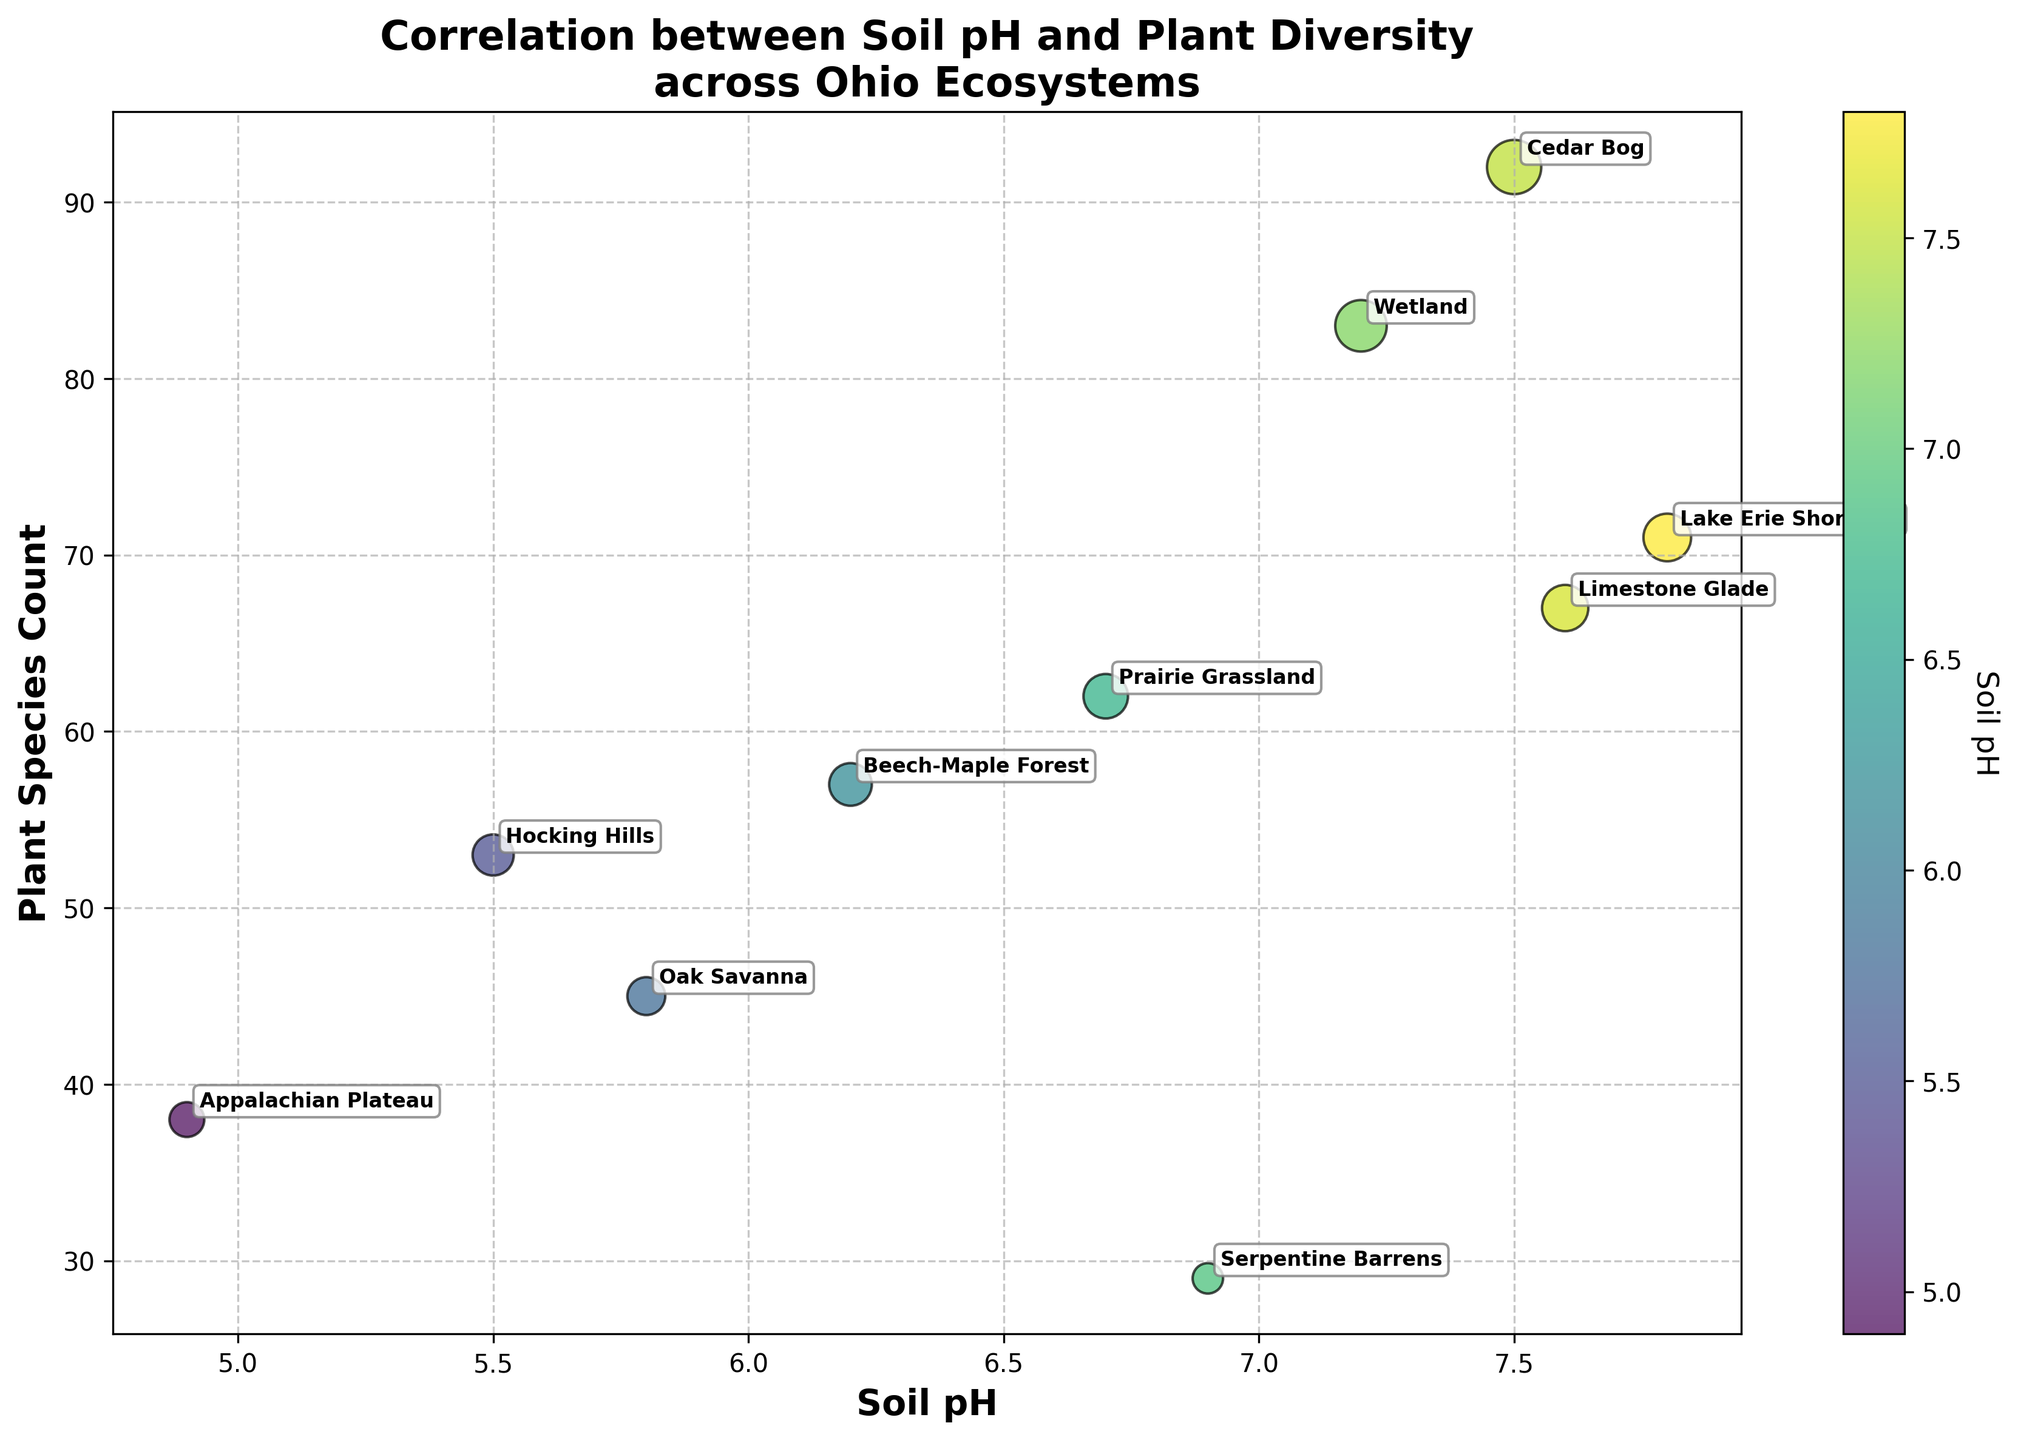what is the correlation between soil pH and plant species count across different ecosystems in Ohio? By observing the bubble chart, which plots soil pH on the x-axis and plant species count on the y-axis, we can evaluate the trend and relationship between these two variables. Higher pH levels generally correlate with more plant species, though with some exceptions.
Answer: Positive correlation Which ecosystem has the highest plant species count? According to the bubble chart, the Cedar Bog, with a soil pH of 7.5, has the highest plant species count.
Answer: Cedar Bog What is the range of soil pH levels represented in the chart? The x-axis of the chart shows the soil pH levels, ranging from a minimum of 4.9 (Appalachian Plateau) to a maximum of 7.8 (Lake Erie Shoreline).
Answer: 4.9 to 7.8 Which ecosystem has the lowest soil pH, and what is its corresponding plant species count? The ecosystem with the lowest soil pH of 4.9 is the Appalachian Plateau, which has a plant species count of 38.
Answer: Appalachian Plateau, 38 How does the plant species count of Oak Savanna compare to that of Beech-Maple Forest? Both ecosystems have different pH levels and plant species counts. The Oak Savanna has a soil pH of 5.8 and 45 plant species, whereas the Beech-Maple Forest has a soil pH of 6.2 and 57 plant species. The Beech-Maple Forest has a higher plant species count.
Answer: Beech-Maple Forest has more species What trend can you observe between soil pH and plant species count when comparing the highest and lowest plant diversity ecosystems? Cedar Bog, with a soil pH of 7.5, has the highest plant species count (92), while Serpentine Barrens, with a soil pH of 6.9, has the lowest plant species count (29). Higher soil pH does not necessarily mean the highest plant species count; the relationship is not linear.
Answer: No strict linear trend Is there any ecosystem where a higher species count is associated with relatively lower soil pH? Hocking Hills has a lower soil pH of 5.5 but still supports a robust plant species count of 53, which is relatively high.
Answer: Hocking Hills Which ecosystems have similar soil pH but different plant species counts? Wetland (7.2 pH, 83 species) and Limestone Glade (7.6 pH, 67 species) have similar pH levels but different plant species counts, with Wetland having more species.
Answer: Wetland and Limestone Glade What’s the average plant species count for ecosystems with a soil pH greater than 7.0? Calculate the average plant species count for Wetland (83), Cedar Bog (92), Lake Erie Shoreline (71), and Limestone Glade (67): (83 + 92 + 71 + 67) / 4 = 313 / 4 = 78.25.
Answer: 78.25 What’s the difference in plant species counts between the most acidic and most alkaline environments? The most acidic environment is the Appalachian Plateau (pH 4.9, 38 species). The most alkaline is Lake Erie Shoreline (pH 7.8, 71 species). The difference is 71 - 38 = 33.
Answer: 33 